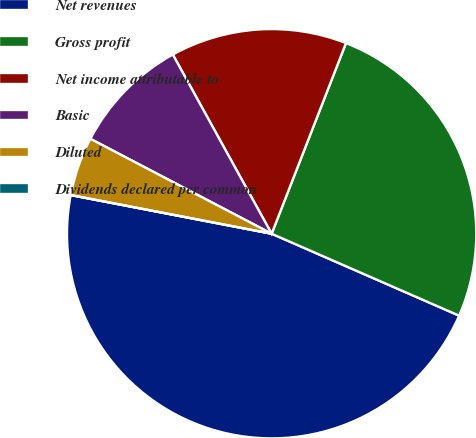<chart> <loc_0><loc_0><loc_500><loc_500><pie_chart><fcel>Net revenues<fcel>Gross profit<fcel>Net income attributable to<fcel>Basic<fcel>Diluted<fcel>Dividends declared per common<nl><fcel>46.47%<fcel>25.64%<fcel>13.94%<fcel>9.3%<fcel>4.65%<fcel>0.0%<nl></chart> 